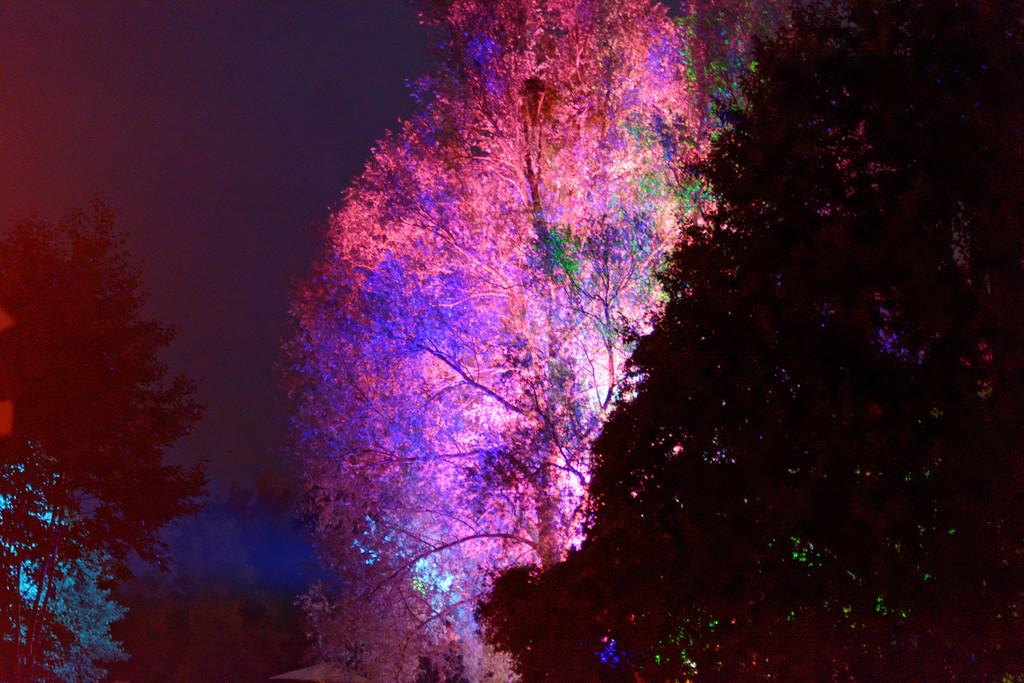What type of natural elements can be seen in the image? There are trees in the image. What type of artificial elements can be seen in the image? There are colorful lights in the image. Can you describe any other objects present in the image? There are other objects in the image, but their specific nature is not mentioned in the provided facts. What time of day is depicted in the image? The background of the image is at night. Is there a beggar asking for money in the image? There is no mention of a beggar in the provided facts, so we cannot determine if one is present in the image. What type of building can be seen in the image? There is no mention of a building in the provided facts, so we cannot determine if one is present in the image. 